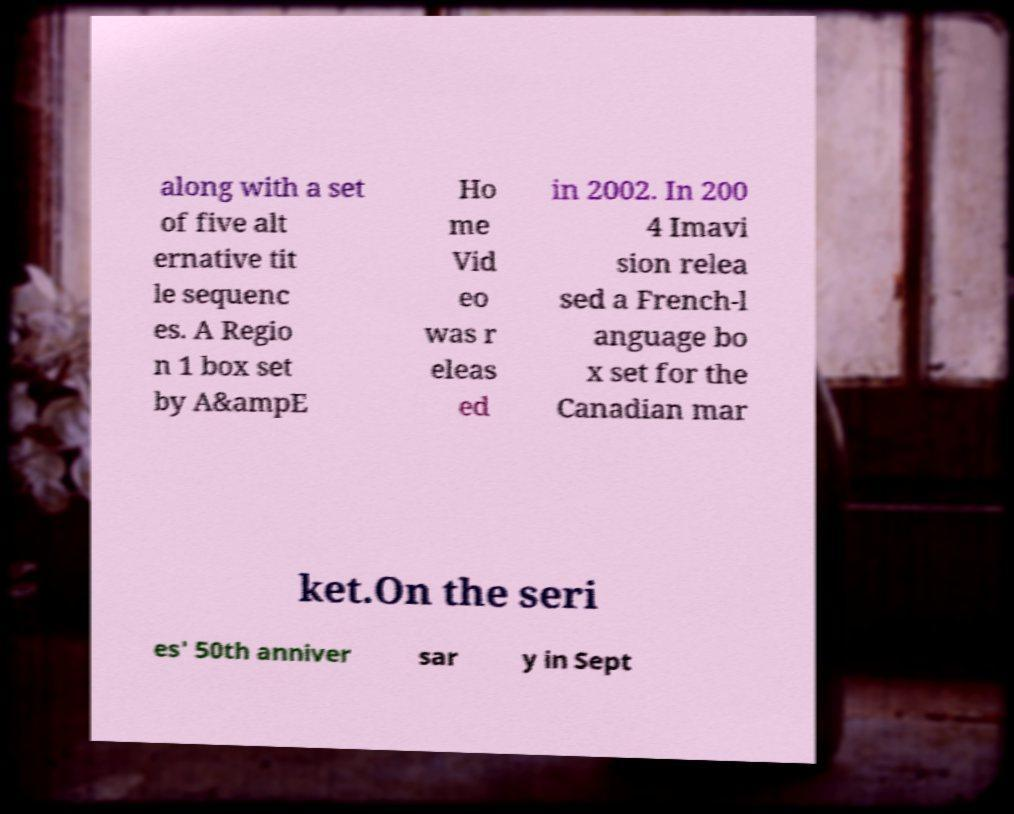What messages or text are displayed in this image? I need them in a readable, typed format. along with a set of five alt ernative tit le sequenc es. A Regio n 1 box set by A&ampE Ho me Vid eo was r eleas ed in 2002. In 200 4 Imavi sion relea sed a French-l anguage bo x set for the Canadian mar ket.On the seri es' 50th anniver sar y in Sept 